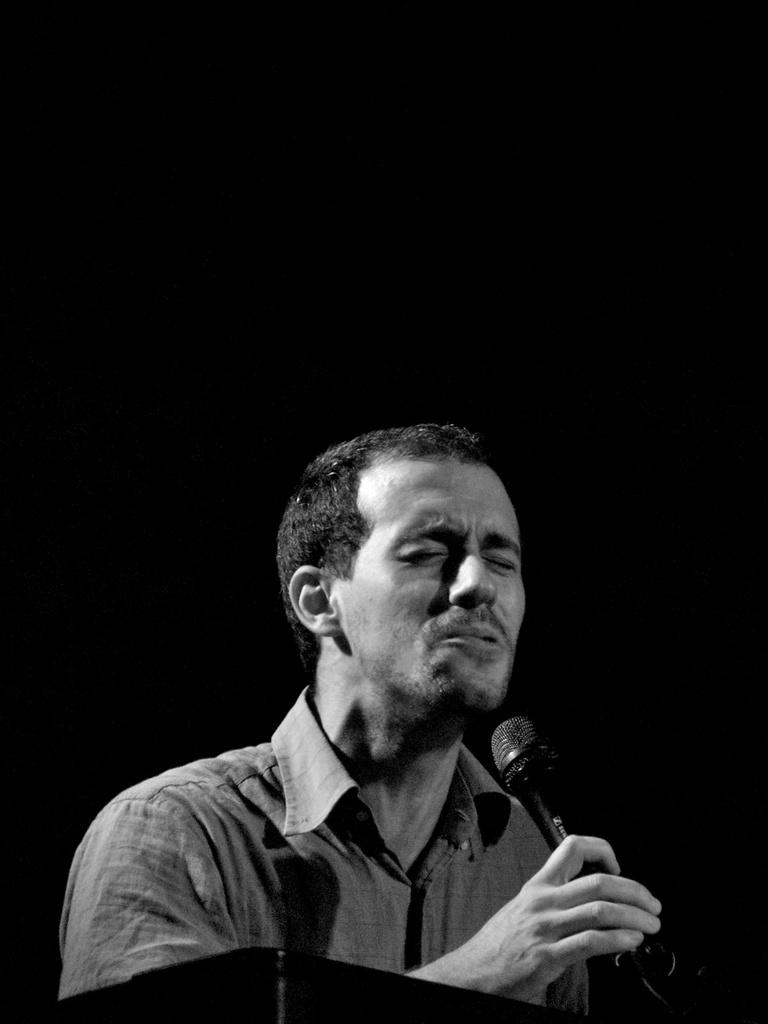What is the main subject of the image? The main subject of the image is a man. What is the man doing in the image? The man is standing in the image. What object is the man holding in his hand? The man is holding a mic in his hand. What invention is the man demonstrating in the image? There is no invention being demonstrated in the image; the man is simply holding a mic. How many times does the man roll in the image? The man does not roll in the image; he is standing and holding a mic. 